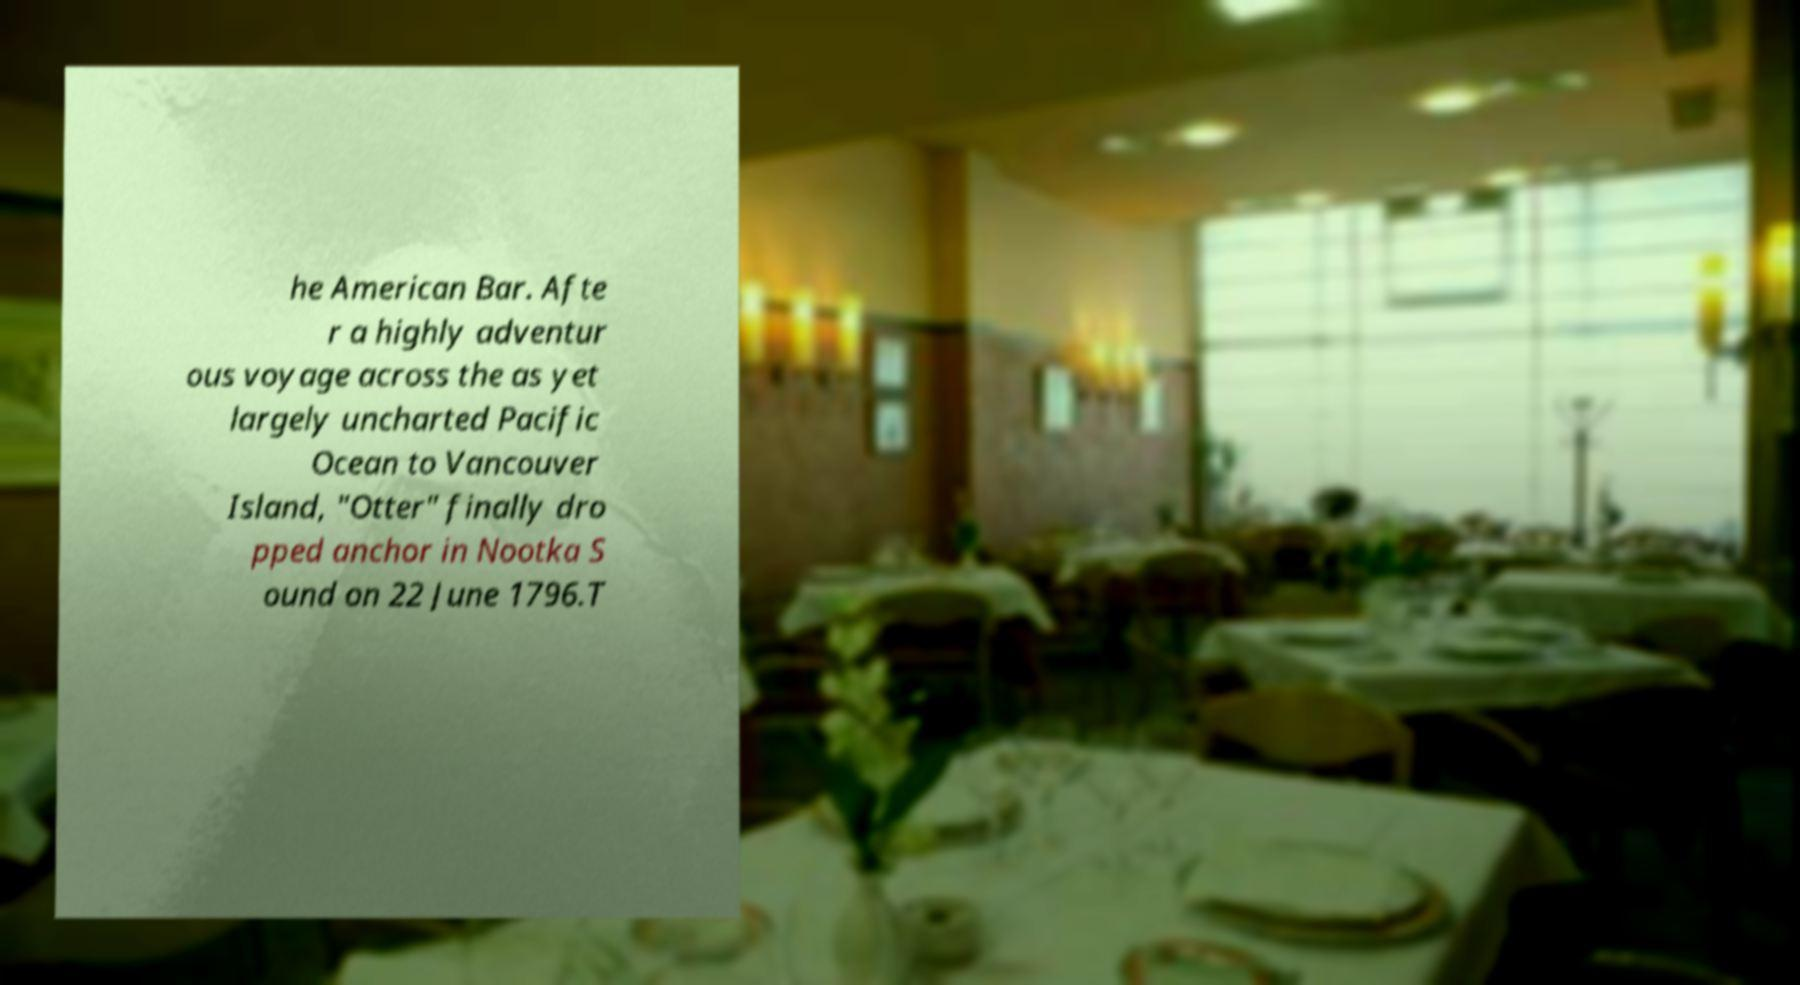Could you extract and type out the text from this image? he American Bar. Afte r a highly adventur ous voyage across the as yet largely uncharted Pacific Ocean to Vancouver Island, "Otter" finally dro pped anchor in Nootka S ound on 22 June 1796.T 